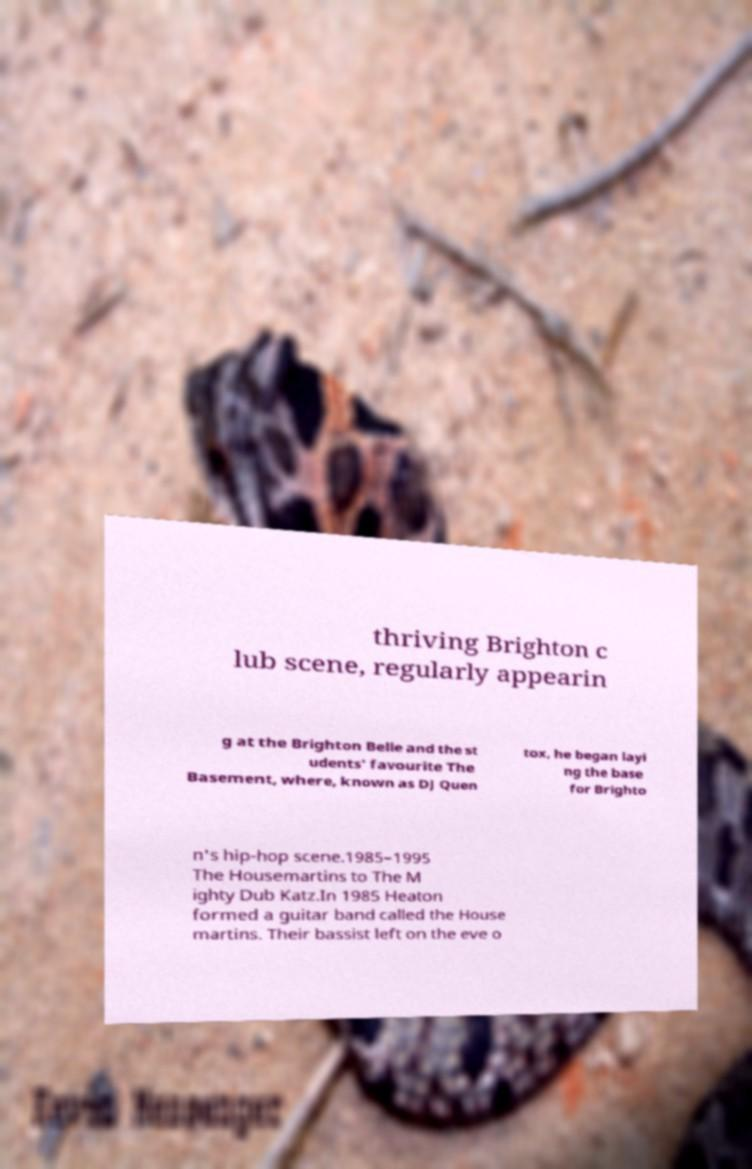Please identify and transcribe the text found in this image. thriving Brighton c lub scene, regularly appearin g at the Brighton Belle and the st udents' favourite The Basement, where, known as DJ Quen tox, he began layi ng the base for Brighto n's hip-hop scene.1985–1995 The Housemartins to The M ighty Dub Katz.In 1985 Heaton formed a guitar band called the House martins. Their bassist left on the eve o 